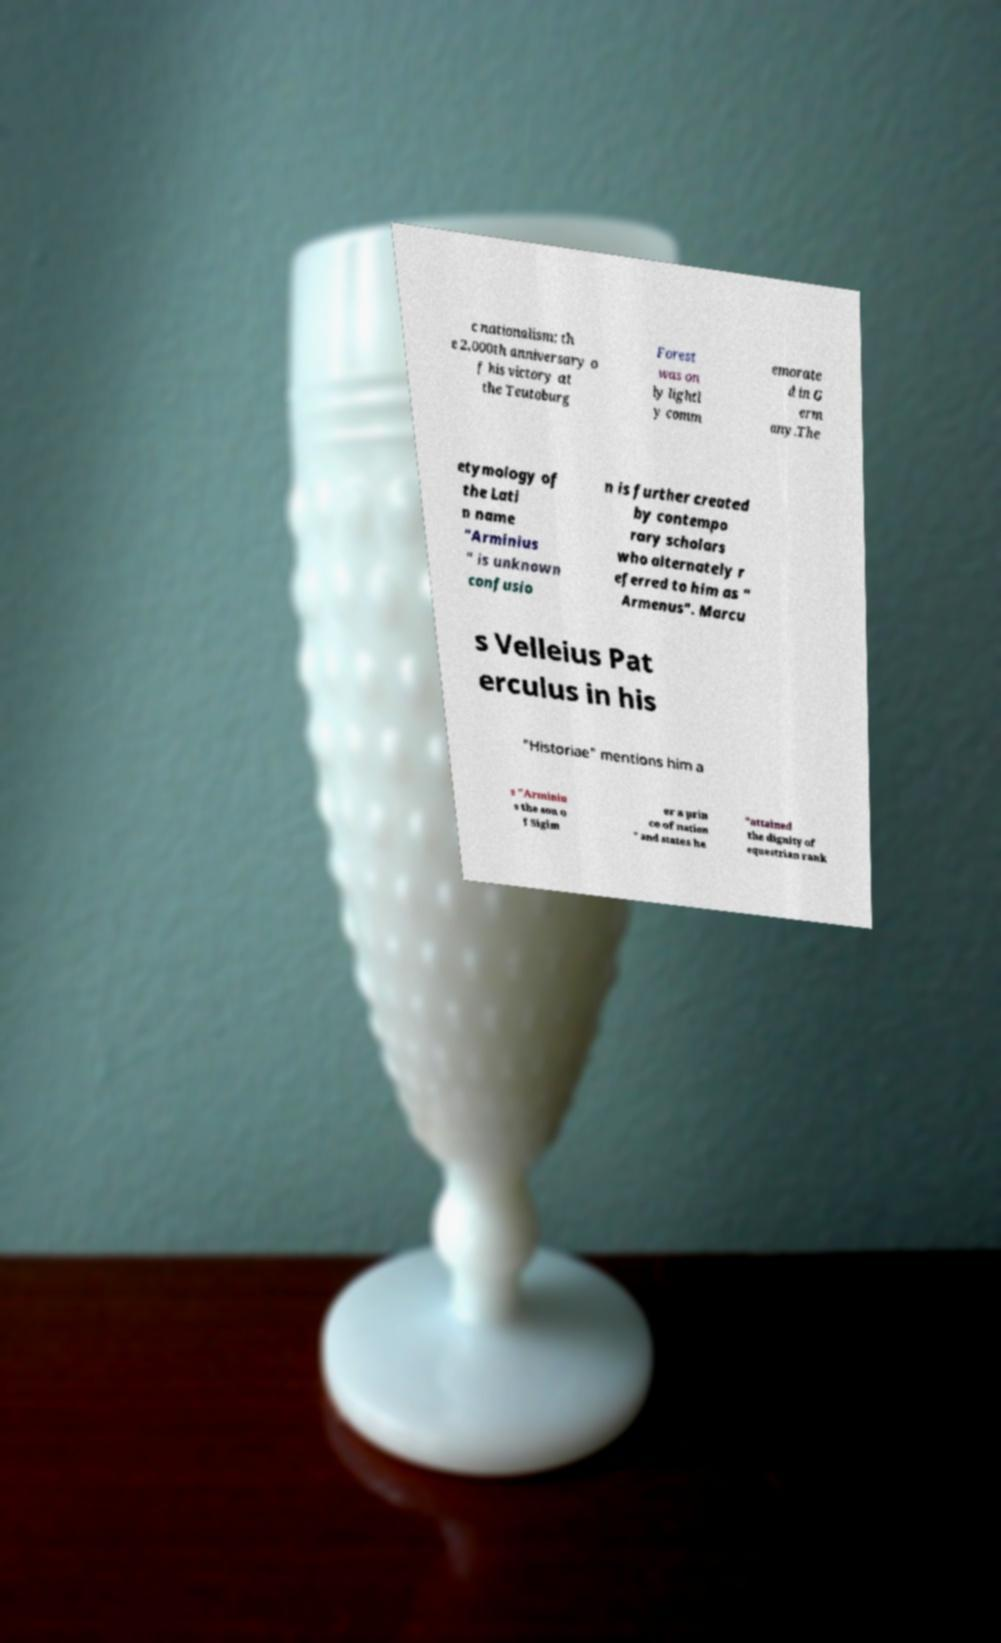Can you read and provide the text displayed in the image?This photo seems to have some interesting text. Can you extract and type it out for me? c nationalism; th e 2,000th anniversary o f his victory at the Teutoburg Forest was on ly lightl y comm emorate d in G erm any.The etymology of the Lati n name "Arminius " is unknown confusio n is further created by contempo rary scholars who alternately r eferred to him as " Armenus". Marcu s Velleius Pat erculus in his "Historiae" mentions him a s "Arminiu s the son o f Sigim er a prin ce of nation " and states he "attained the dignity of equestrian rank 